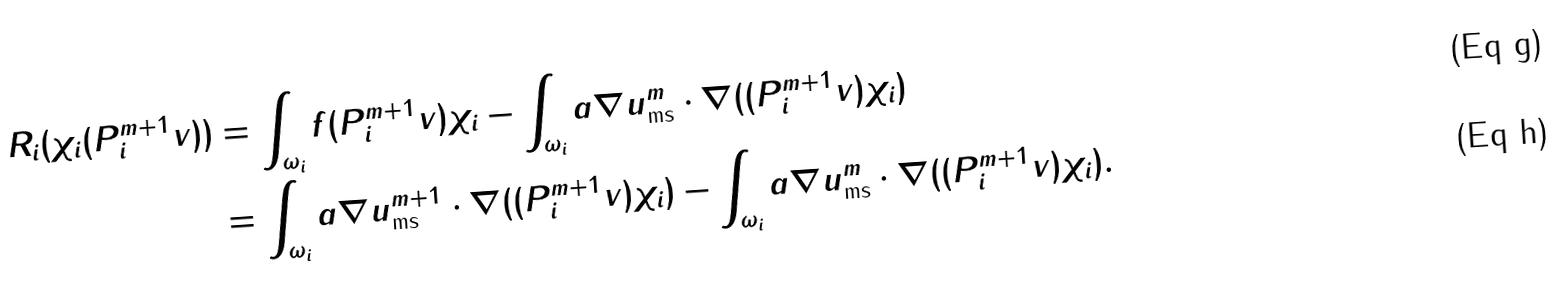Convert formula to latex. <formula><loc_0><loc_0><loc_500><loc_500>R _ { i } ( \chi _ { i } ( P _ { i } ^ { m + 1 } v ) ) & = \int _ { \omega _ { i } } f ( P _ { i } ^ { m + 1 } v ) \chi _ { i } - \int _ { \omega _ { i } } a \nabla u ^ { m } _ { \text {ms} } \cdot \nabla ( ( P _ { i } ^ { m + 1 } v ) \chi _ { i } ) \\ & = \int _ { \omega _ { i } } a \nabla u ^ { m + 1 } _ { \text {ms} } \cdot \nabla ( ( P _ { i } ^ { m + 1 } v ) \chi _ { i } ) - \int _ { \omega _ { i } } a \nabla u ^ { m } _ { \text {ms} } \cdot \nabla ( ( P _ { i } ^ { m + 1 } v ) \chi _ { i } ) .</formula> 